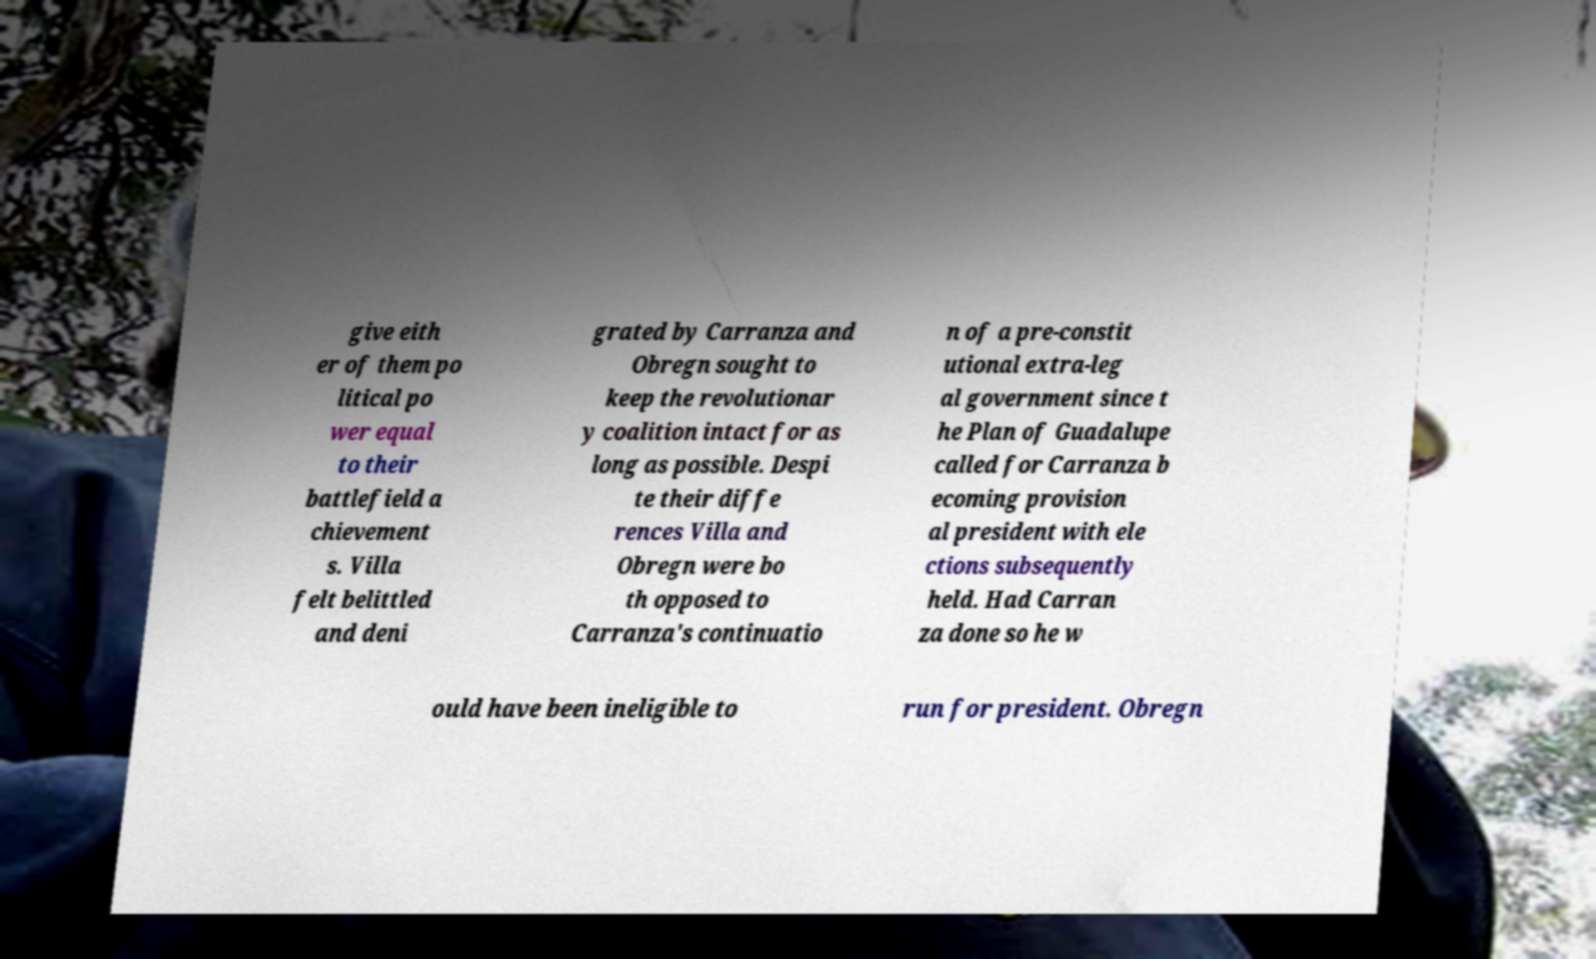Can you read and provide the text displayed in the image?This photo seems to have some interesting text. Can you extract and type it out for me? give eith er of them po litical po wer equal to their battlefield a chievement s. Villa felt belittled and deni grated by Carranza and Obregn sought to keep the revolutionar y coalition intact for as long as possible. Despi te their diffe rences Villa and Obregn were bo th opposed to Carranza's continuatio n of a pre-constit utional extra-leg al government since t he Plan of Guadalupe called for Carranza b ecoming provision al president with ele ctions subsequently held. Had Carran za done so he w ould have been ineligible to run for president. Obregn 